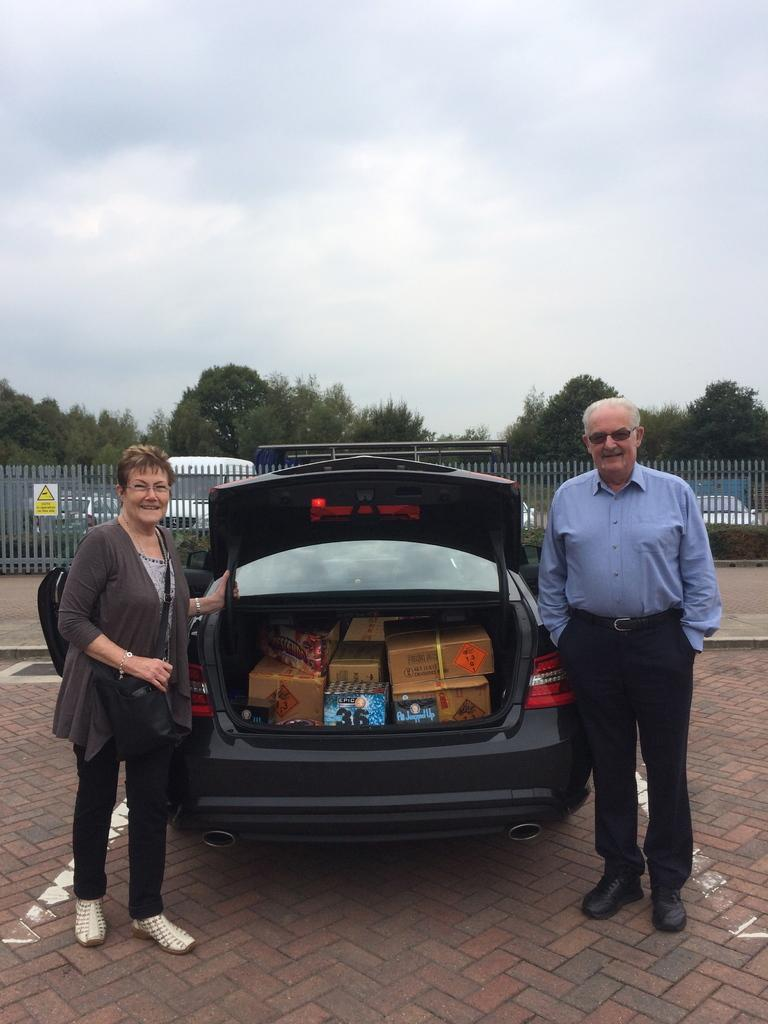How many people are in the image? There are two people in the image. What is the facial expression of the people in the image? The people are smiling. Where are the people located in the image? The people are standing on the road. What else can be seen in the image besides the people? There are vehicles, boxes, a fence, trees, and some objects in the image. What is visible in the background of the image? The sky is visible in the background of the image. What type of boundary is present in the image? There is no specific boundary mentioned or visible in the image. What place is the image taken at? The image does not provide enough information to determine the exact location or place. 